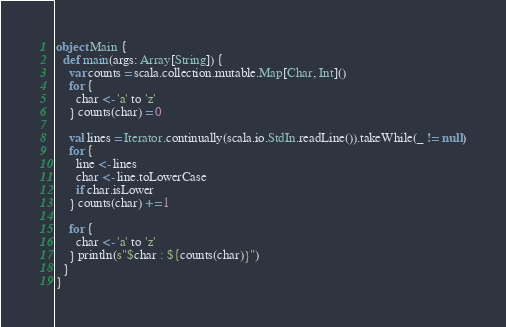<code> <loc_0><loc_0><loc_500><loc_500><_Scala_>object Main {
  def main(args: Array[String]) {
    var counts = scala.collection.mutable.Map[Char, Int]()
    for {
      char <- 'a' to 'z'
    } counts(char) = 0

    val lines = Iterator.continually(scala.io.StdIn.readLine()).takeWhile(_ != null)
    for {
      line <- lines
      char <- line.toLowerCase
      if char.isLower
    } counts(char) += 1

    for {
      char <- 'a' to 'z'
    } println(s"$char : ${counts(char)}")
  }
}</code> 